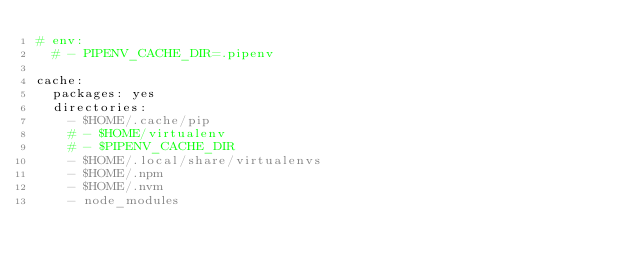Convert code to text. <code><loc_0><loc_0><loc_500><loc_500><_YAML_># env:
  # - PIPENV_CACHE_DIR=.pipenv

cache:
  packages: yes
  directories:
    - $HOME/.cache/pip
    # - $HOME/virtualenv
    # - $PIPENV_CACHE_DIR
    - $HOME/.local/share/virtualenvs
    - $HOME/.npm
    - $HOME/.nvm
    - node_modules
</code> 